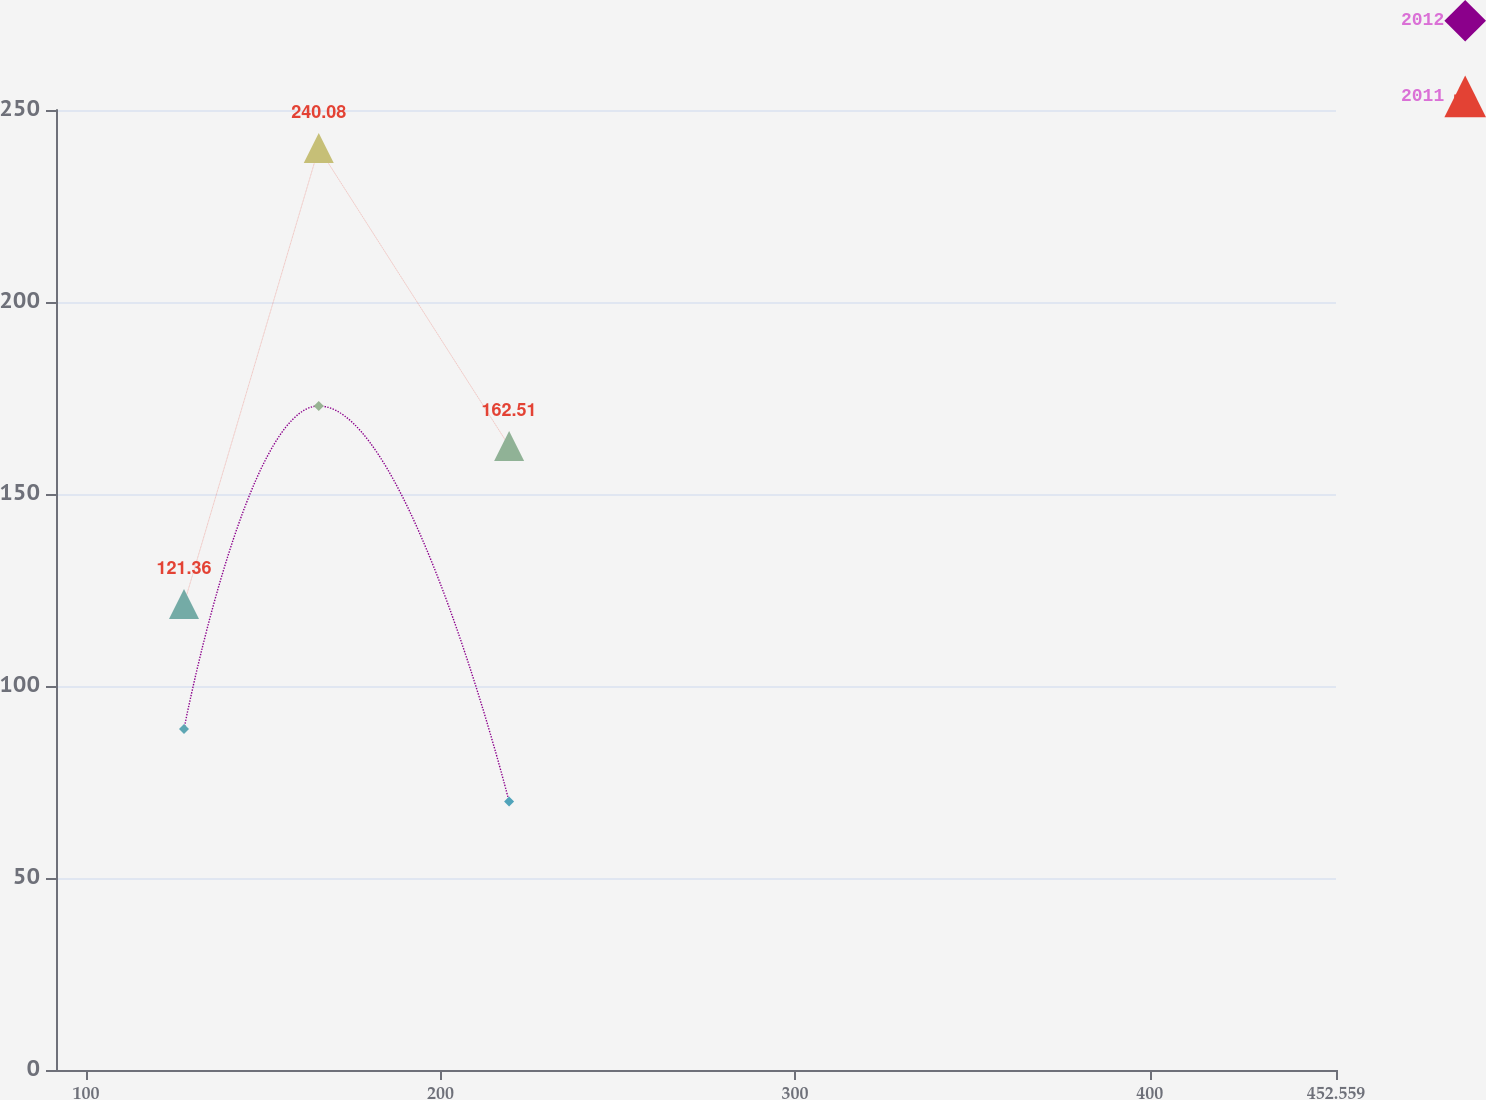<chart> <loc_0><loc_0><loc_500><loc_500><line_chart><ecel><fcel>2012<fcel>2011<nl><fcel>127.65<fcel>88.8<fcel>121.36<nl><fcel>165.65<fcel>172.94<fcel>240.08<nl><fcel>219.34<fcel>69.9<fcel>162.51<nl><fcel>488.66<fcel>258.88<fcel>514.89<nl></chart> 